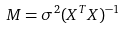Convert formula to latex. <formula><loc_0><loc_0><loc_500><loc_500>M = \sigma ^ { 2 } ( X ^ { T } X ) ^ { - 1 }</formula> 